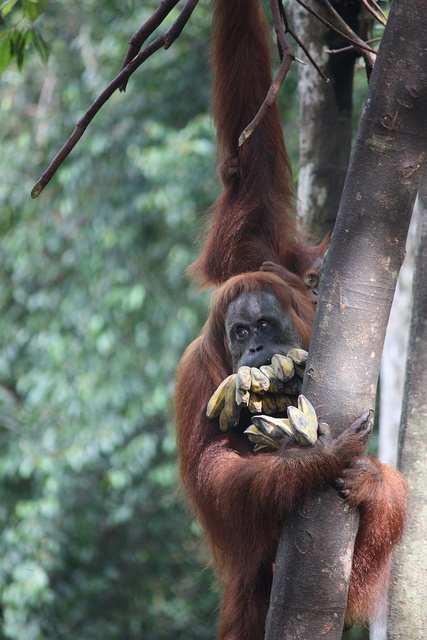Describe the objects in this image and their specific colors. I can see banana in gray, lightgray, black, and darkgray tones, banana in gray, darkgray, and black tones, banana in gray, beige, black, and maroon tones, banana in gray, tan, and black tones, and banana in gray, lightgray, black, darkgray, and tan tones in this image. 